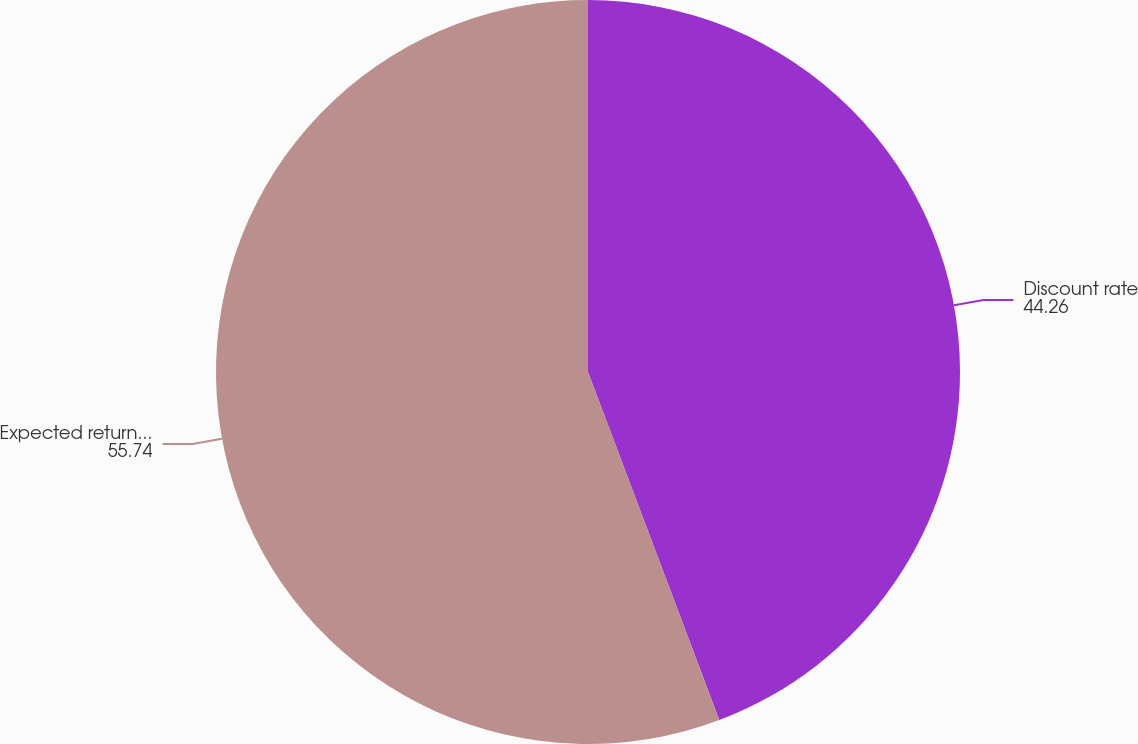<chart> <loc_0><loc_0><loc_500><loc_500><pie_chart><fcel>Discount rate<fcel>Expected return on plan assets<nl><fcel>44.26%<fcel>55.74%<nl></chart> 